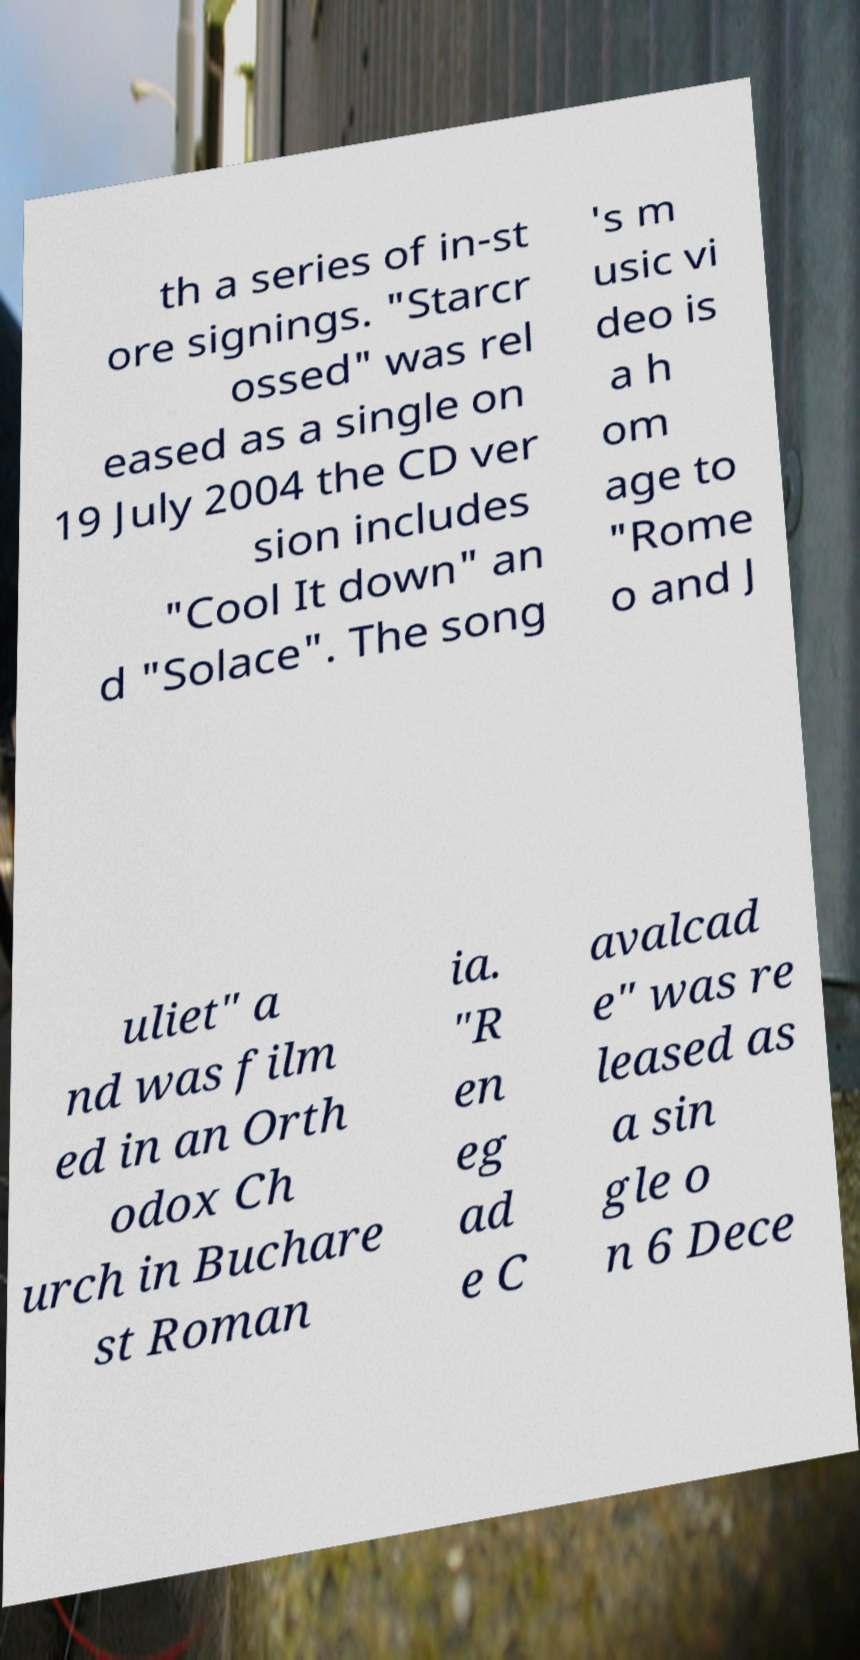For documentation purposes, I need the text within this image transcribed. Could you provide that? th a series of in-st ore signings. "Starcr ossed" was rel eased as a single on 19 July 2004 the CD ver sion includes "Cool It down" an d "Solace". The song 's m usic vi deo is a h om age to "Rome o and J uliet" a nd was film ed in an Orth odox Ch urch in Buchare st Roman ia. "R en eg ad e C avalcad e" was re leased as a sin gle o n 6 Dece 